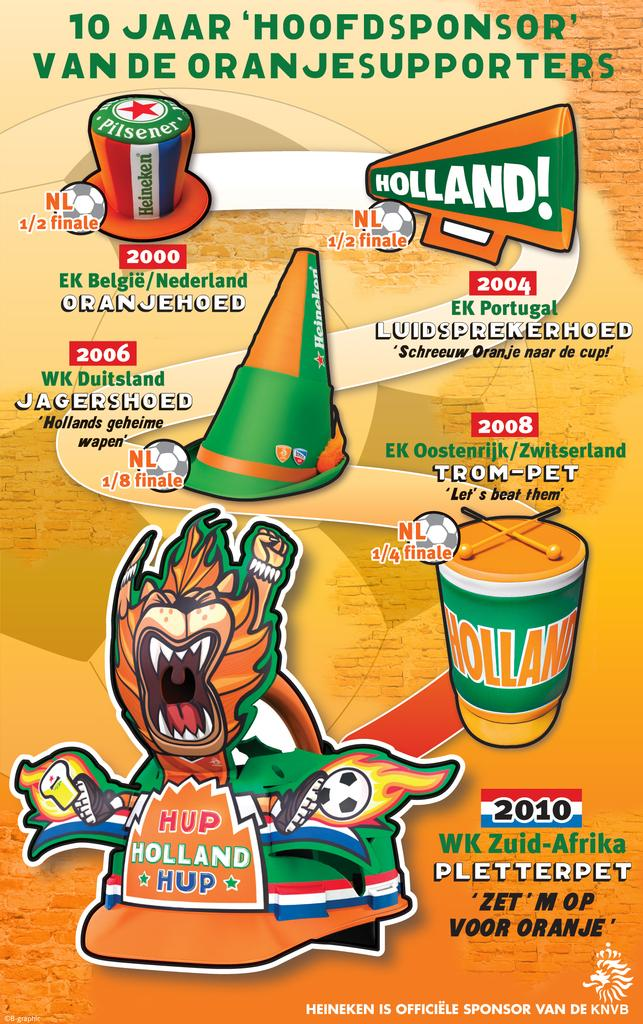What is present in the image that contains information or visuals? There is a poster in the image. What types of elements can be found on the poster? The poster contains objects, text, and numbers. What type of copper apparatus can be seen in the image? There is no copper apparatus present in the image; the image only contains a poster with objects, text, and numbers. 